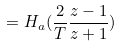<formula> <loc_0><loc_0><loc_500><loc_500>= H _ { a } ( \frac { 2 } { T } \frac { z - 1 } { z + 1 } )</formula> 